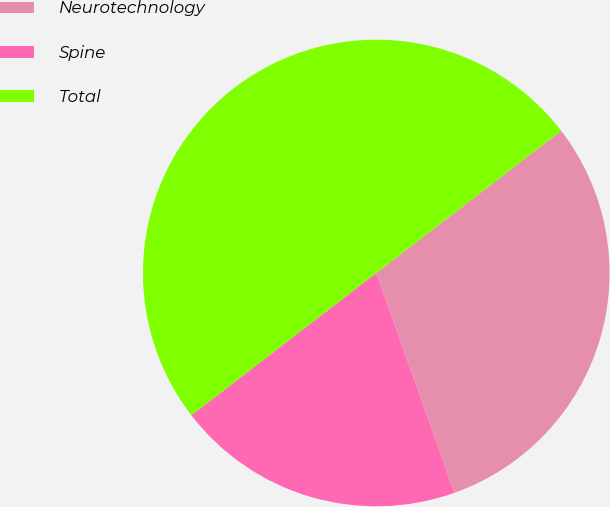Convert chart to OTSL. <chart><loc_0><loc_0><loc_500><loc_500><pie_chart><fcel>Neurotechnology<fcel>Spine<fcel>Total<nl><fcel>30.0%<fcel>20.0%<fcel>50.0%<nl></chart> 